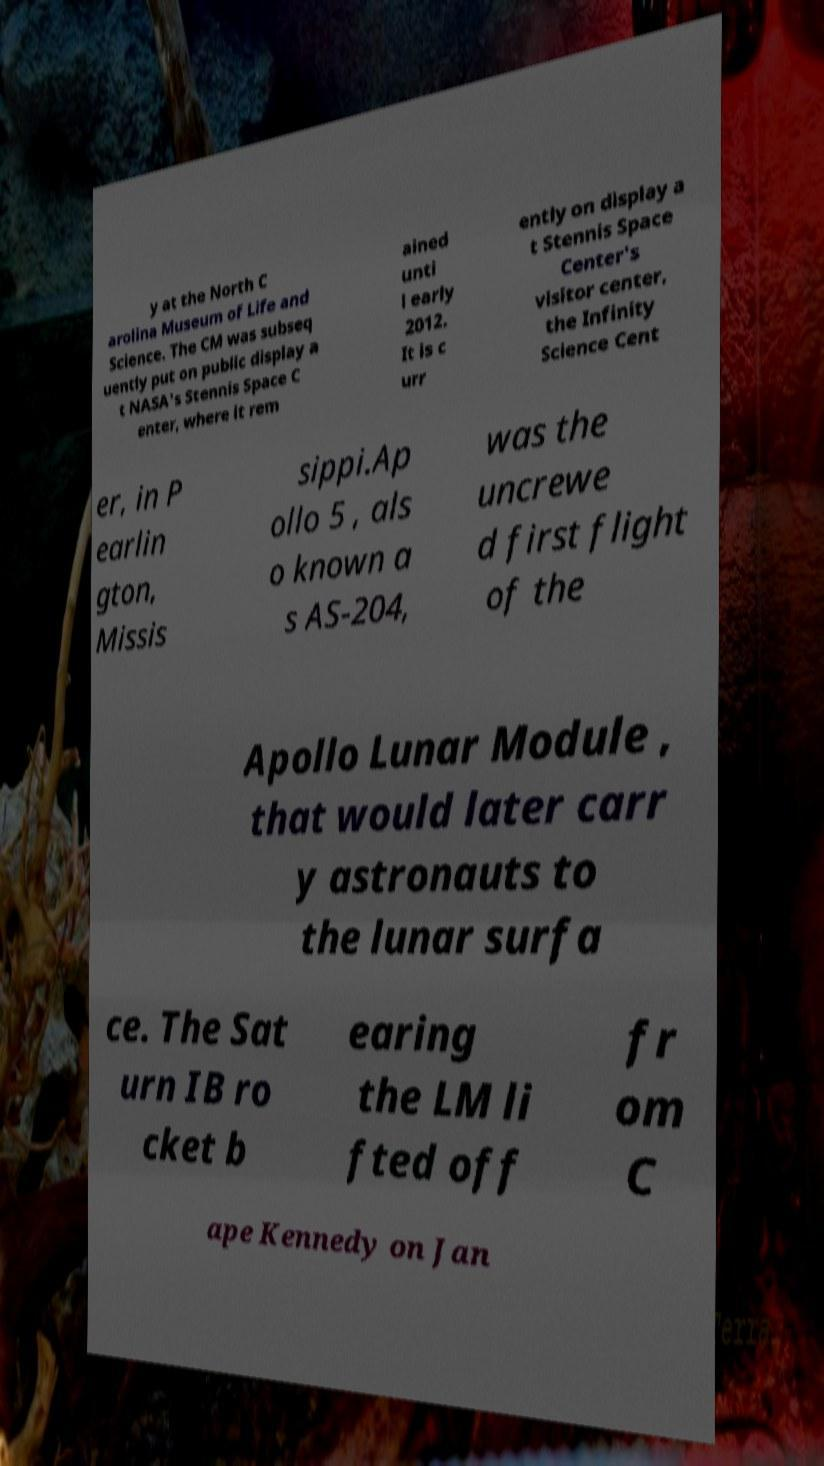Can you read and provide the text displayed in the image?This photo seems to have some interesting text. Can you extract and type it out for me? y at the North C arolina Museum of Life and Science. The CM was subseq uently put on public display a t NASA's Stennis Space C enter, where it rem ained unti l early 2012. It is c urr ently on display a t Stennis Space Center's visitor center, the Infinity Science Cent er, in P earlin gton, Missis sippi.Ap ollo 5 , als o known a s AS-204, was the uncrewe d first flight of the Apollo Lunar Module , that would later carr y astronauts to the lunar surfa ce. The Sat urn IB ro cket b earing the LM li fted off fr om C ape Kennedy on Jan 